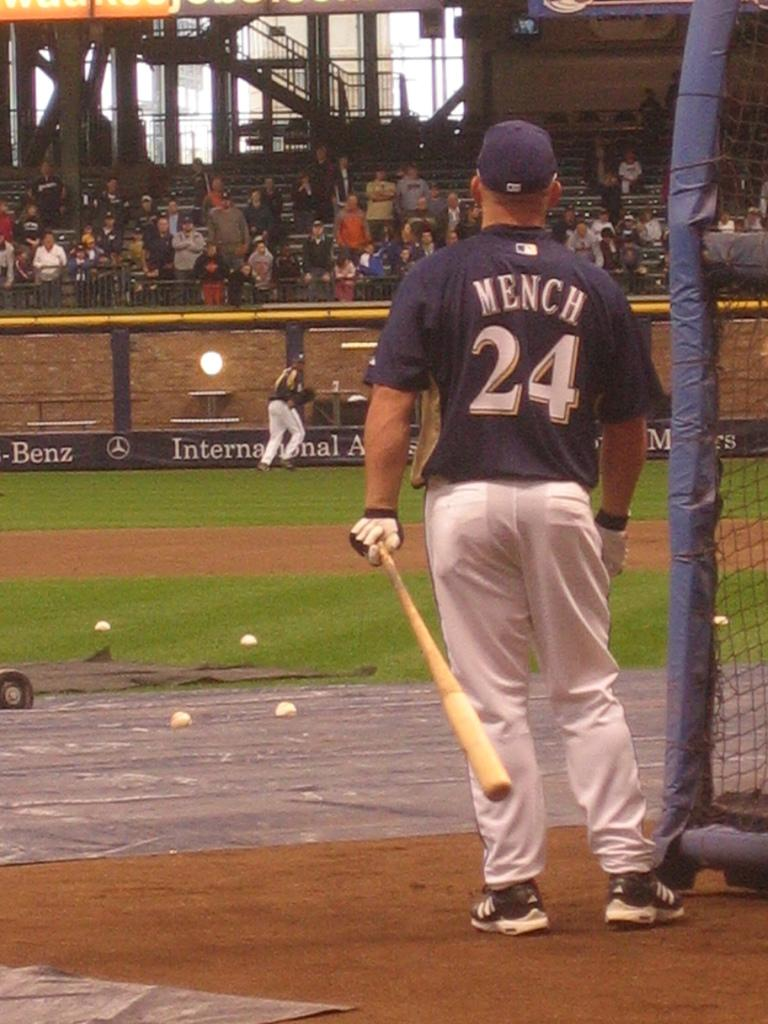<image>
Create a compact narrative representing the image presented. a player that has the number 24 on their jersey 